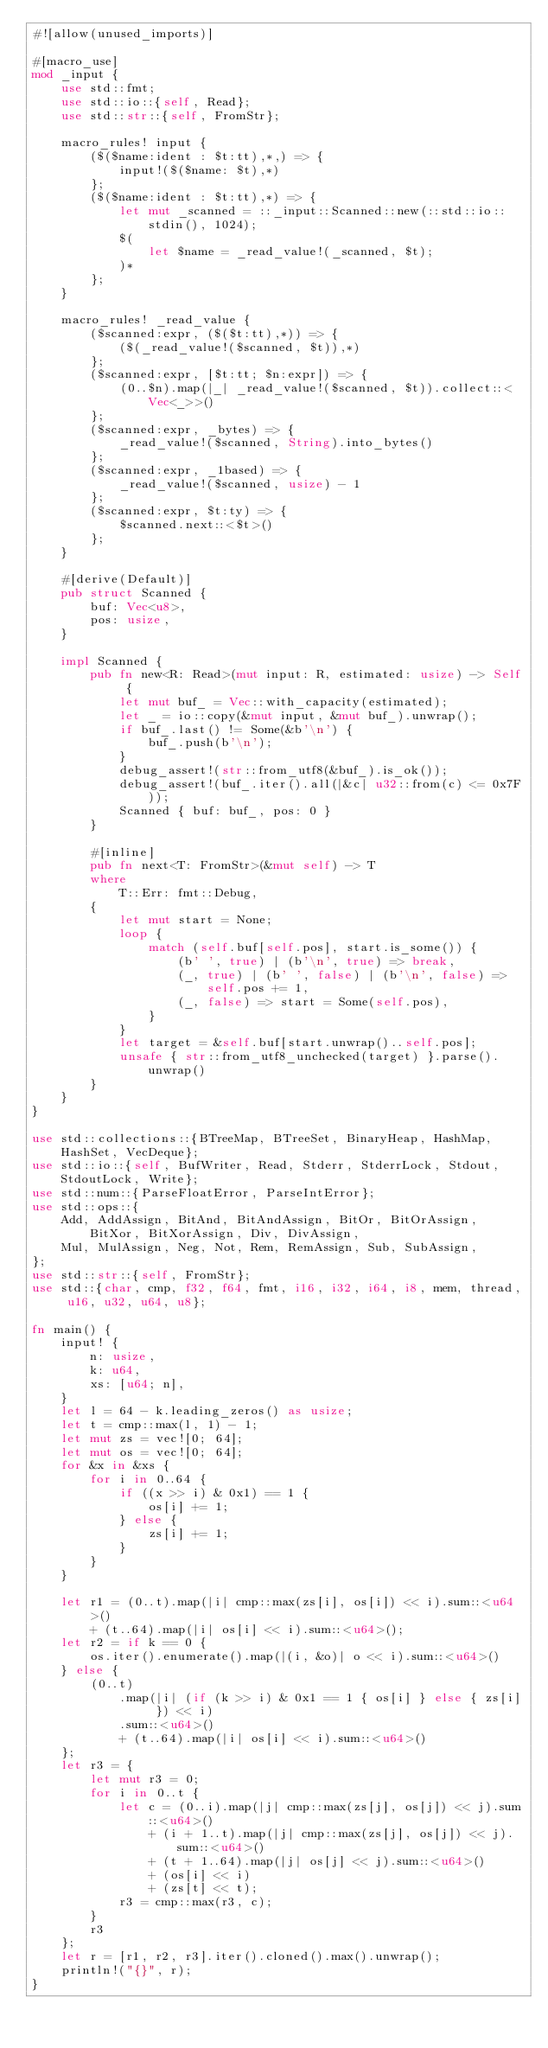Convert code to text. <code><loc_0><loc_0><loc_500><loc_500><_Rust_>#![allow(unused_imports)]

#[macro_use]
mod _input {
    use std::fmt;
    use std::io::{self, Read};
    use std::str::{self, FromStr};

    macro_rules! input {
        ($($name:ident : $t:tt),*,) => {
            input!($($name: $t),*)
        };
        ($($name:ident : $t:tt),*) => {
            let mut _scanned = ::_input::Scanned::new(::std::io::stdin(), 1024);
            $(
                let $name = _read_value!(_scanned, $t);
            )*
        };
    }

    macro_rules! _read_value {
        ($scanned:expr, ($($t:tt),*)) => {
            ($(_read_value!($scanned, $t)),*)
        };
        ($scanned:expr, [$t:tt; $n:expr]) => {
            (0..$n).map(|_| _read_value!($scanned, $t)).collect::<Vec<_>>()
        };
        ($scanned:expr, _bytes) => {
            _read_value!($scanned, String).into_bytes()
        };
        ($scanned:expr, _1based) => {
            _read_value!($scanned, usize) - 1
        };
        ($scanned:expr, $t:ty) => {
            $scanned.next::<$t>()
        };
    }

    #[derive(Default)]
    pub struct Scanned {
        buf: Vec<u8>,
        pos: usize,
    }

    impl Scanned {
        pub fn new<R: Read>(mut input: R, estimated: usize) -> Self {
            let mut buf_ = Vec::with_capacity(estimated);
            let _ = io::copy(&mut input, &mut buf_).unwrap();
            if buf_.last() != Some(&b'\n') {
                buf_.push(b'\n');
            }
            debug_assert!(str::from_utf8(&buf_).is_ok());
            debug_assert!(buf_.iter().all(|&c| u32::from(c) <= 0x7F));
            Scanned { buf: buf_, pos: 0 }
        }

        #[inline]
        pub fn next<T: FromStr>(&mut self) -> T
        where
            T::Err: fmt::Debug,
        {
            let mut start = None;
            loop {
                match (self.buf[self.pos], start.is_some()) {
                    (b' ', true) | (b'\n', true) => break,
                    (_, true) | (b' ', false) | (b'\n', false) => self.pos += 1,
                    (_, false) => start = Some(self.pos),
                }
            }
            let target = &self.buf[start.unwrap()..self.pos];
            unsafe { str::from_utf8_unchecked(target) }.parse().unwrap()
        }
    }
}

use std::collections::{BTreeMap, BTreeSet, BinaryHeap, HashMap, HashSet, VecDeque};
use std::io::{self, BufWriter, Read, Stderr, StderrLock, Stdout, StdoutLock, Write};
use std::num::{ParseFloatError, ParseIntError};
use std::ops::{
    Add, AddAssign, BitAnd, BitAndAssign, BitOr, BitOrAssign, BitXor, BitXorAssign, Div, DivAssign,
    Mul, MulAssign, Neg, Not, Rem, RemAssign, Sub, SubAssign,
};
use std::str::{self, FromStr};
use std::{char, cmp, f32, f64, fmt, i16, i32, i64, i8, mem, thread, u16, u32, u64, u8};

fn main() {
    input! {
        n: usize,
        k: u64,
        xs: [u64; n],
    }
    let l = 64 - k.leading_zeros() as usize;
    let t = cmp::max(l, 1) - 1;
    let mut zs = vec![0; 64];
    let mut os = vec![0; 64];
    for &x in &xs {
        for i in 0..64 {
            if ((x >> i) & 0x1) == 1 {
                os[i] += 1;
            } else {
                zs[i] += 1;
            }
        }
    }

    let r1 = (0..t).map(|i| cmp::max(zs[i], os[i]) << i).sum::<u64>()
        + (t..64).map(|i| os[i] << i).sum::<u64>();
    let r2 = if k == 0 {
        os.iter().enumerate().map(|(i, &o)| o << i).sum::<u64>()
    } else {
        (0..t)
            .map(|i| (if (k >> i) & 0x1 == 1 { os[i] } else { zs[i] }) << i)
            .sum::<u64>()
            + (t..64).map(|i| os[i] << i).sum::<u64>()
    };
    let r3 = {
        let mut r3 = 0;
        for i in 0..t {
            let c = (0..i).map(|j| cmp::max(zs[j], os[j]) << j).sum::<u64>()
                + (i + 1..t).map(|j| cmp::max(zs[j], os[j]) << j).sum::<u64>()
                + (t + 1..64).map(|j| os[j] << j).sum::<u64>()
                + (os[i] << i)
                + (zs[t] << t);
            r3 = cmp::max(r3, c);
        }
        r3
    };
    let r = [r1, r2, r3].iter().cloned().max().unwrap();
    println!("{}", r);
}
</code> 